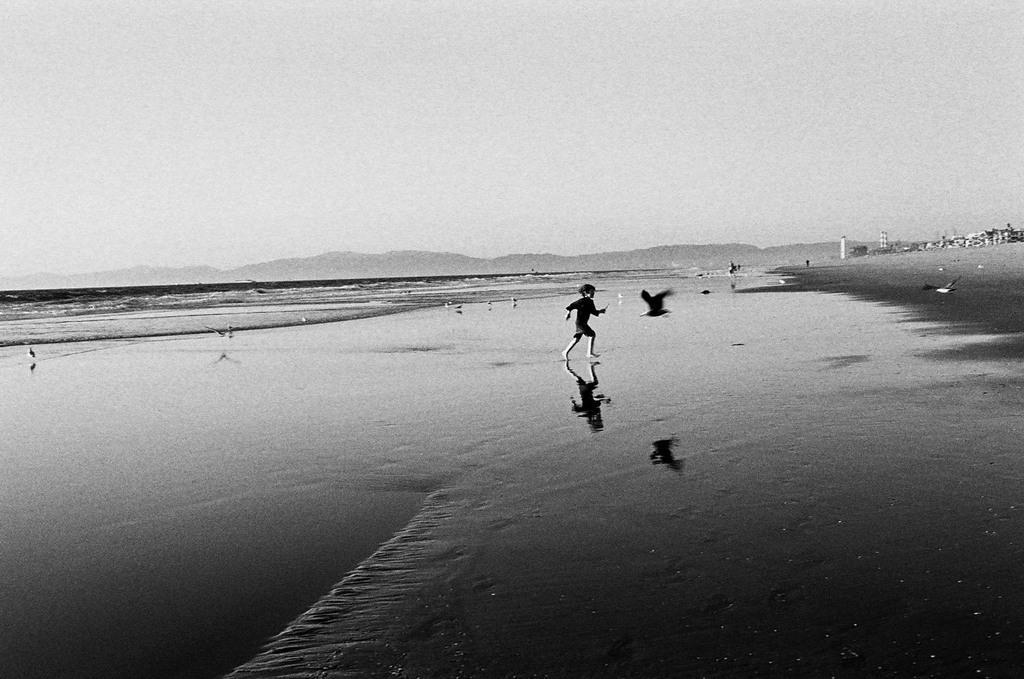Could you give a brief overview of what you see in this image? There is a kid running in water and there is a bird flying beside him and there are few buildings in the right corner and there are water in the left corner. 